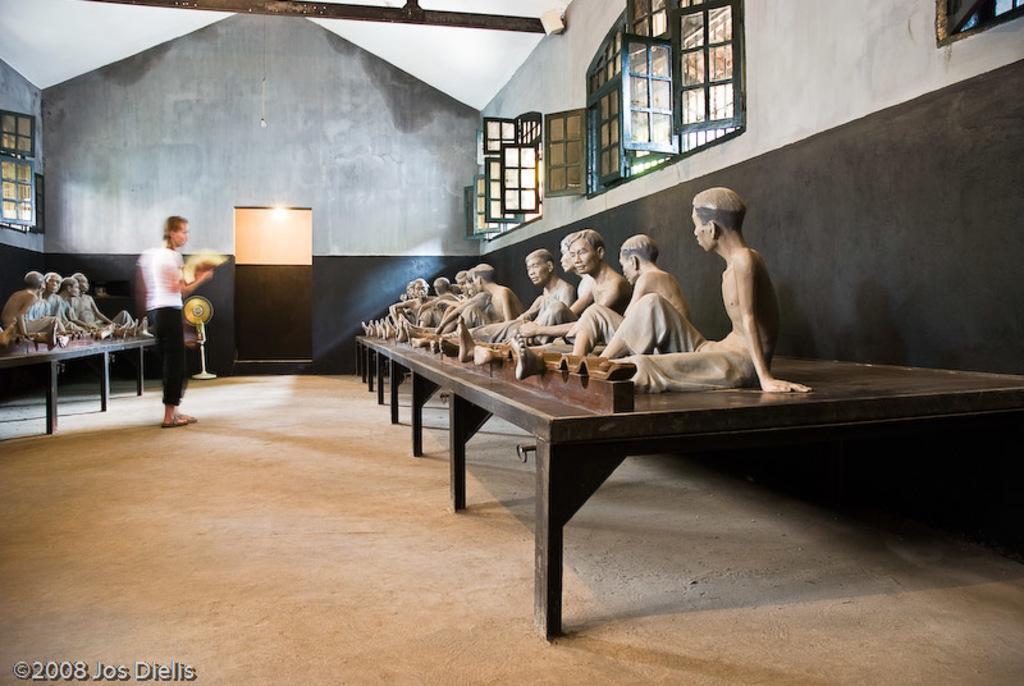How would you summarize this image in a sentence or two? At the center of the image there is a person standing and holding an object. On the right and left side of the image there are few people sitting on the table. In the background there is a wall and windows. 